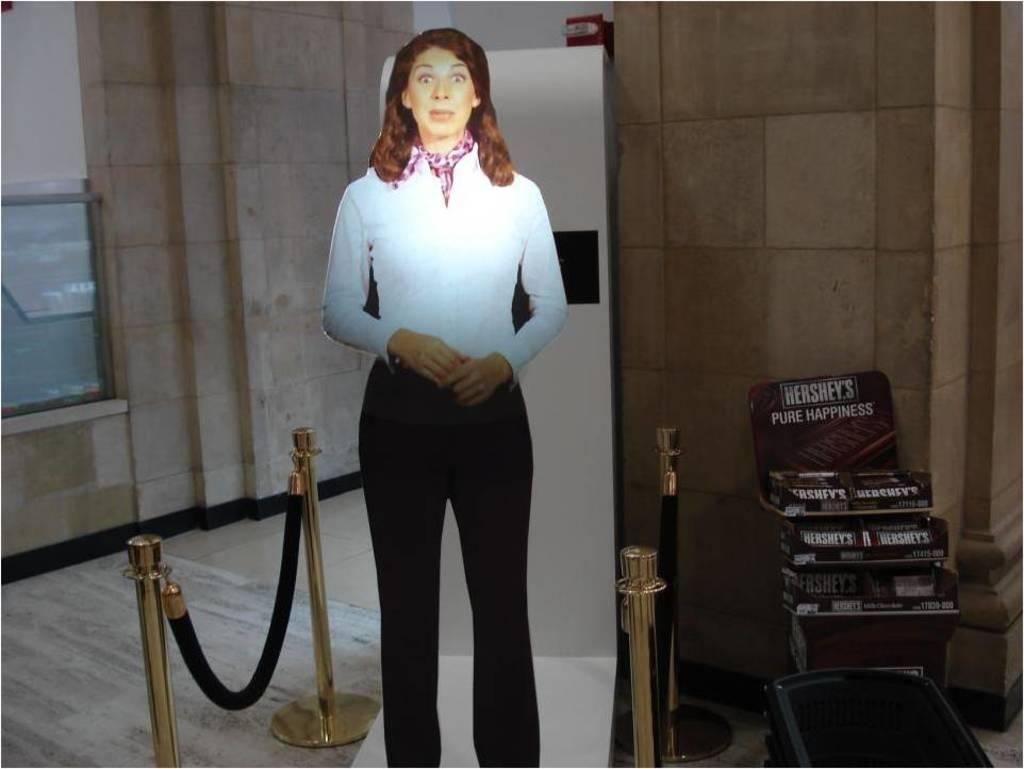<image>
Offer a succinct explanation of the picture presented. A box of Hershey's chocolate promises pure happiness. 